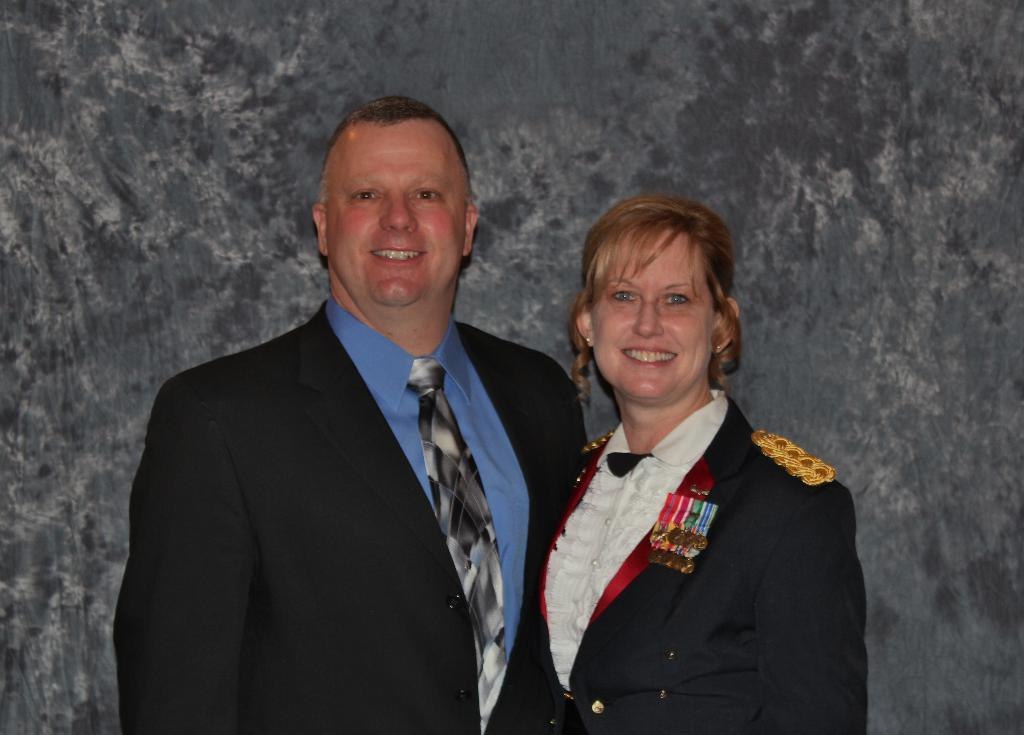Who are the people in the image? There is a man and a woman in the image. What are the expressions on their faces? Both the man and the woman are smiling in the image. What can be seen in the background of the image? There is a wall in the background of the image. What type of brush is the man using to paint the van in the image? There is no brush, van, or painting activity present in the image. 